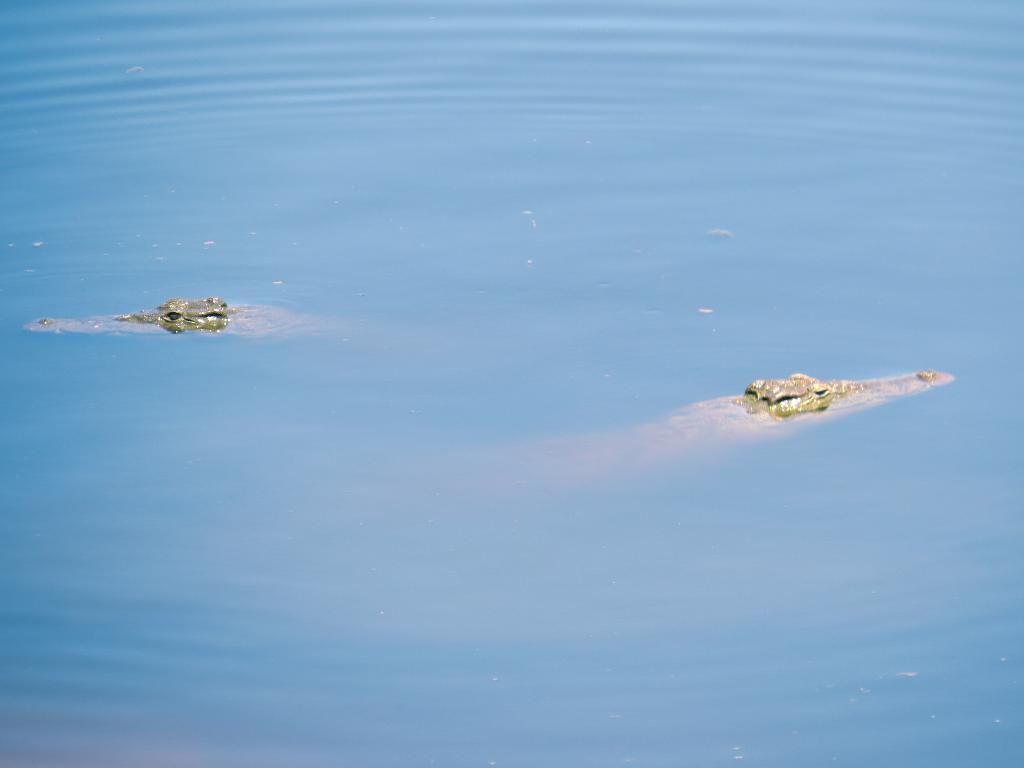In one or two sentences, can you explain what this image depicts? In the picture I can see two crocodiles in the water. 